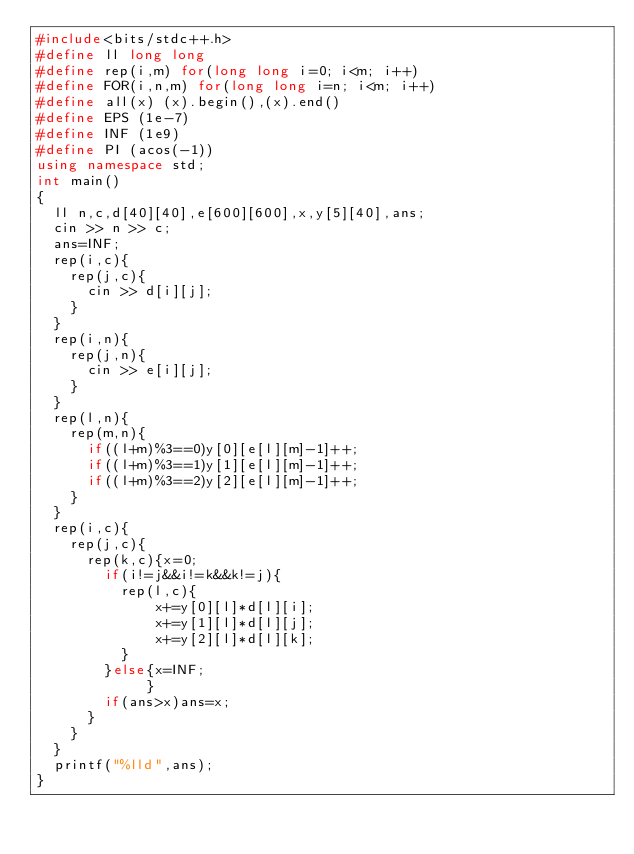Convert code to text. <code><loc_0><loc_0><loc_500><loc_500><_C++_>#include<bits/stdc++.h>
#define ll long long
#define rep(i,m) for(long long i=0; i<m; i++)
#define FOR(i,n,m) for(long long i=n; i<m; i++)
#define all(x) (x).begin(),(x).end()
#define EPS (1e-7)
#define INF (1e9)
#define PI (acos(-1))
using namespace std;
int main()
{
  ll n,c,d[40][40],e[600][600],x,y[5][40],ans;
  cin >> n >> c;
  ans=INF;
  rep(i,c){
    rep(j,c){
      cin >> d[i][j];
    }
  }
  rep(i,n){
    rep(j,n){
      cin >> e[i][j];
    }
  }
  rep(l,n){
    rep(m,n){
      if((l+m)%3==0)y[0][e[l][m]-1]++;
      if((l+m)%3==1)y[1][e[l][m]-1]++;
      if((l+m)%3==2)y[2][e[l][m]-1]++;
    }
  }
  rep(i,c){
    rep(j,c){
      rep(k,c){x=0;
        if(i!=j&&i!=k&&k!=j){
          rep(l,c){
              x+=y[0][l]*d[l][i];
              x+=y[1][l]*d[l][j];
              x+=y[2][l]*d[l][k];
          }
        }else{x=INF;
             }
        if(ans>x)ans=x;
      }
    }
  }
  printf("%lld",ans);
}</code> 